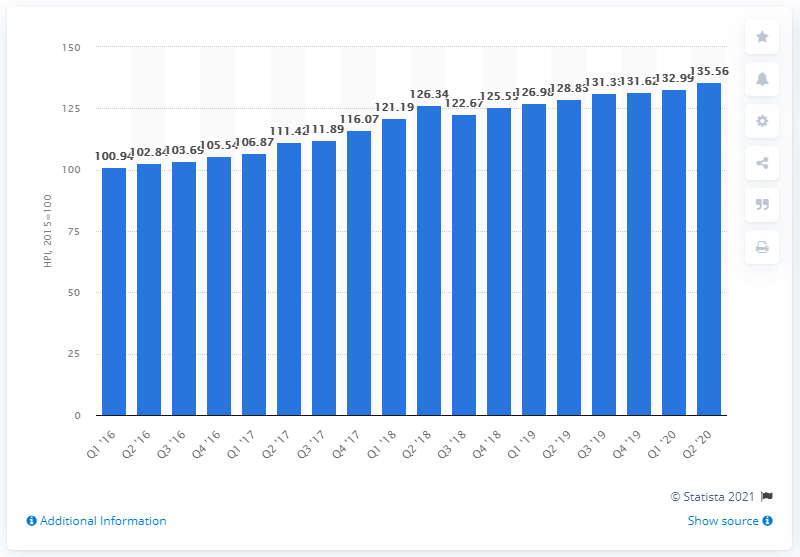Indicate a few pertinent items in this graphic. Slovenia's house price index in the quarter ending June 2020 was 135.56. 